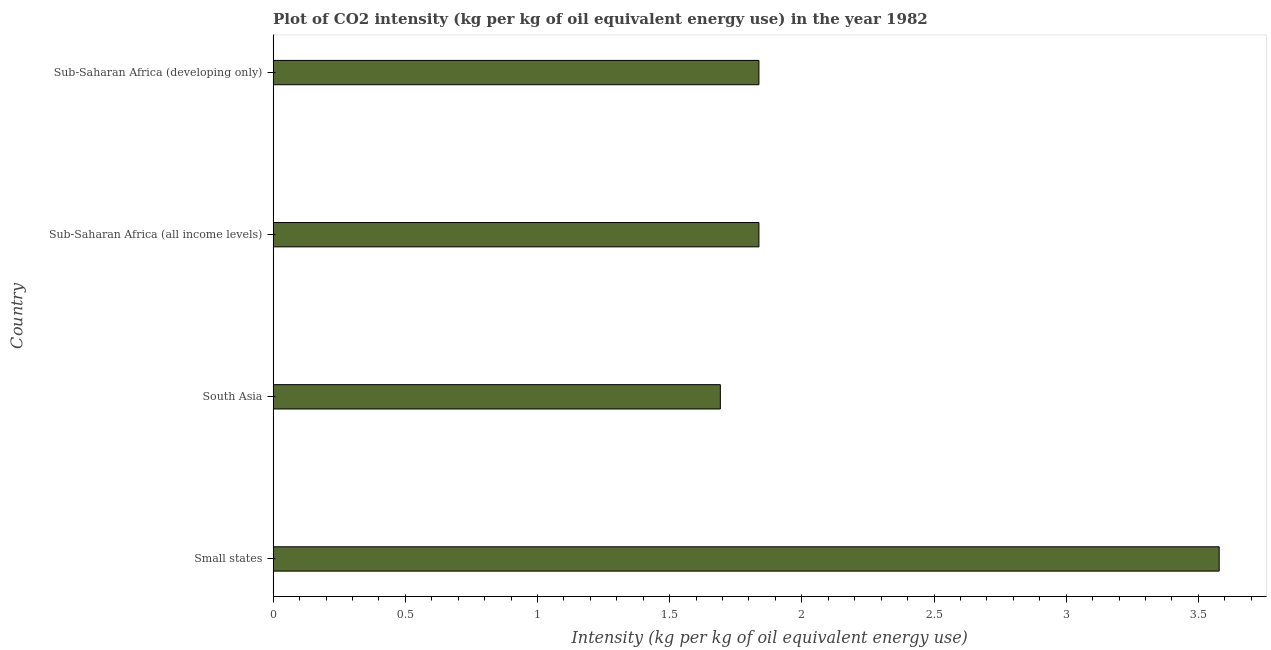Does the graph contain any zero values?
Provide a succinct answer. No. What is the title of the graph?
Give a very brief answer. Plot of CO2 intensity (kg per kg of oil equivalent energy use) in the year 1982. What is the label or title of the X-axis?
Keep it short and to the point. Intensity (kg per kg of oil equivalent energy use). What is the label or title of the Y-axis?
Offer a very short reply. Country. What is the co2 intensity in Sub-Saharan Africa (developing only)?
Your answer should be very brief. 1.84. Across all countries, what is the maximum co2 intensity?
Offer a very short reply. 3.58. Across all countries, what is the minimum co2 intensity?
Your response must be concise. 1.69. In which country was the co2 intensity maximum?
Keep it short and to the point. Small states. In which country was the co2 intensity minimum?
Keep it short and to the point. South Asia. What is the sum of the co2 intensity?
Make the answer very short. 8.95. What is the difference between the co2 intensity in Small states and Sub-Saharan Africa (developing only)?
Provide a succinct answer. 1.74. What is the average co2 intensity per country?
Provide a short and direct response. 2.24. What is the median co2 intensity?
Offer a terse response. 1.84. In how many countries, is the co2 intensity greater than 2.8 kg?
Make the answer very short. 1. What is the ratio of the co2 intensity in Small states to that in Sub-Saharan Africa (developing only)?
Provide a short and direct response. 1.95. Is the difference between the co2 intensity in Small states and Sub-Saharan Africa (all income levels) greater than the difference between any two countries?
Provide a short and direct response. No. What is the difference between the highest and the second highest co2 intensity?
Your response must be concise. 1.74. What is the difference between the highest and the lowest co2 intensity?
Provide a succinct answer. 1.89. In how many countries, is the co2 intensity greater than the average co2 intensity taken over all countries?
Keep it short and to the point. 1. How many bars are there?
Offer a very short reply. 4. Are all the bars in the graph horizontal?
Make the answer very short. Yes. What is the difference between two consecutive major ticks on the X-axis?
Ensure brevity in your answer.  0.5. Are the values on the major ticks of X-axis written in scientific E-notation?
Give a very brief answer. No. What is the Intensity (kg per kg of oil equivalent energy use) of Small states?
Your response must be concise. 3.58. What is the Intensity (kg per kg of oil equivalent energy use) of South Asia?
Keep it short and to the point. 1.69. What is the Intensity (kg per kg of oil equivalent energy use) of Sub-Saharan Africa (all income levels)?
Provide a short and direct response. 1.84. What is the Intensity (kg per kg of oil equivalent energy use) in Sub-Saharan Africa (developing only)?
Your response must be concise. 1.84. What is the difference between the Intensity (kg per kg of oil equivalent energy use) in Small states and South Asia?
Keep it short and to the point. 1.89. What is the difference between the Intensity (kg per kg of oil equivalent energy use) in Small states and Sub-Saharan Africa (all income levels)?
Offer a very short reply. 1.74. What is the difference between the Intensity (kg per kg of oil equivalent energy use) in Small states and Sub-Saharan Africa (developing only)?
Provide a short and direct response. 1.74. What is the difference between the Intensity (kg per kg of oil equivalent energy use) in South Asia and Sub-Saharan Africa (all income levels)?
Your response must be concise. -0.15. What is the difference between the Intensity (kg per kg of oil equivalent energy use) in South Asia and Sub-Saharan Africa (developing only)?
Keep it short and to the point. -0.15. What is the difference between the Intensity (kg per kg of oil equivalent energy use) in Sub-Saharan Africa (all income levels) and Sub-Saharan Africa (developing only)?
Provide a short and direct response. 0. What is the ratio of the Intensity (kg per kg of oil equivalent energy use) in Small states to that in South Asia?
Your response must be concise. 2.12. What is the ratio of the Intensity (kg per kg of oil equivalent energy use) in Small states to that in Sub-Saharan Africa (all income levels)?
Keep it short and to the point. 1.95. What is the ratio of the Intensity (kg per kg of oil equivalent energy use) in Small states to that in Sub-Saharan Africa (developing only)?
Provide a short and direct response. 1.95. What is the ratio of the Intensity (kg per kg of oil equivalent energy use) in South Asia to that in Sub-Saharan Africa (all income levels)?
Give a very brief answer. 0.92. What is the ratio of the Intensity (kg per kg of oil equivalent energy use) in South Asia to that in Sub-Saharan Africa (developing only)?
Provide a succinct answer. 0.92. 